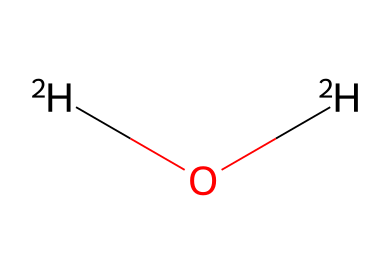What is the molecular formula of the substance depicted? The SMILES representation is [2H]O[2H], which suggests that there are two deuterium (2H) atoms and one oxygen (O) atom, leading to a total of three atoms in the molecule. Thus, the molecular formula is D2O, where D represents deuterium.
Answer: D2O How many hydrogen atoms are in the molecule? The SMILES notation indicates two deuterium atoms (2H), which are isotopes of hydrogen, therefore there are two hydrogen atoms in total when considering their contributions.
Answer: 2 What type of water does this structure represent? The designation D2O indicates it is heavy water, which is water where the hydrogen atoms have been replaced with their heavier isotope deuterium, giving it unique properties compared to regular water (H2O).
Answer: heavy water What is the difference between normal water and this molecule based only on the isotopes? The molecule consists of deuterium, which is an isotope of hydrogen. Normal water has light hydrogen (1H), whereas this molecule has heavy hydrogen, affecting properties such as density and boiling point.
Answer: isotopes What is the total number of bonds present in this molecule? The chemical structure comprises a single bond between each deuterium atom and the oxygen atom. Therefore, totaling these two bonds gives us two bonds for D2O.
Answer: 2 In terms of isotopes, what unique property does deuterium provide compared to ordinary hydrogen? Deuterium has one neutron in addition to its proton, making it nearly twice as heavy as ordinary hydrogen, which significantly affects the physical and chemical properties of compounds formed with deuterium.
Answer: heavier 